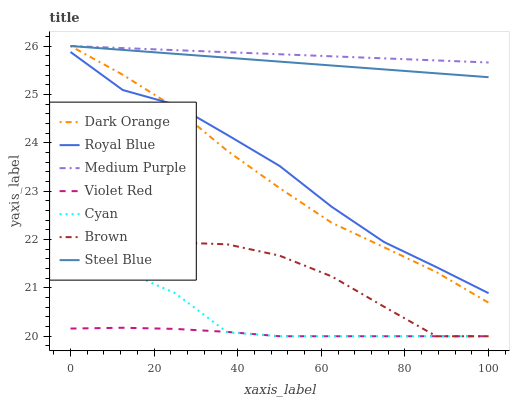Does Brown have the minimum area under the curve?
Answer yes or no. No. Does Brown have the maximum area under the curve?
Answer yes or no. No. Is Violet Red the smoothest?
Answer yes or no. No. Is Violet Red the roughest?
Answer yes or no. No. Does Steel Blue have the lowest value?
Answer yes or no. No. Does Brown have the highest value?
Answer yes or no. No. Is Royal Blue less than Steel Blue?
Answer yes or no. Yes. Is Steel Blue greater than Cyan?
Answer yes or no. Yes. Does Royal Blue intersect Steel Blue?
Answer yes or no. No. 